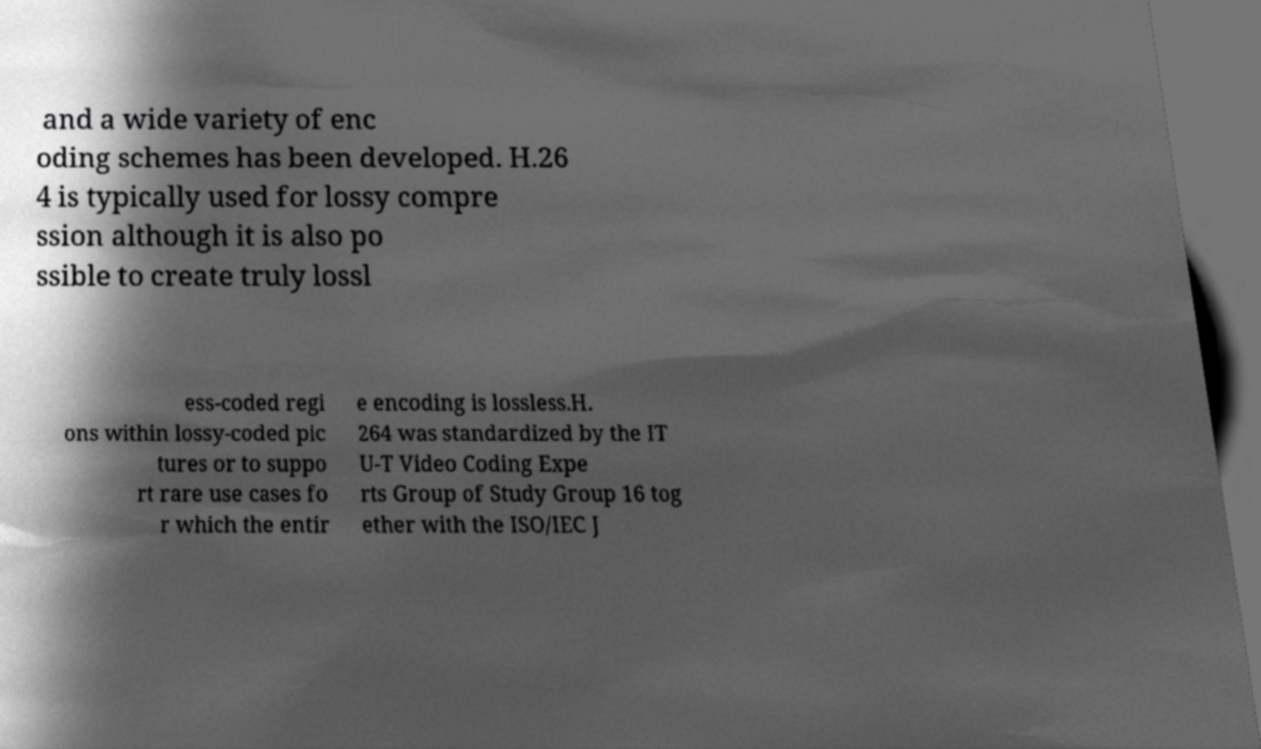Could you extract and type out the text from this image? and a wide variety of enc oding schemes has been developed. H.26 4 is typically used for lossy compre ssion although it is also po ssible to create truly lossl ess-coded regi ons within lossy-coded pic tures or to suppo rt rare use cases fo r which the entir e encoding is lossless.H. 264 was standardized by the IT U-T Video Coding Expe rts Group of Study Group 16 tog ether with the ISO/IEC J 